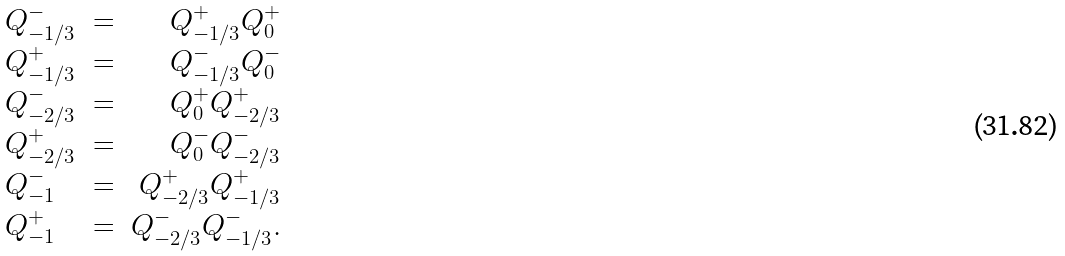<formula> <loc_0><loc_0><loc_500><loc_500>\begin{array} { l c r } Q _ { - 1 / 3 } ^ { - } & = & Q _ { - 1 / 3 } ^ { + } Q _ { 0 } ^ { + } \\ Q _ { - 1 / 3 } ^ { + } & = & Q _ { - 1 / 3 } ^ { - } Q _ { 0 } ^ { - } \\ Q _ { - 2 / 3 } ^ { - } & = & Q _ { 0 } ^ { + } Q _ { - 2 / 3 } ^ { + } \\ Q _ { - 2 / 3 } ^ { + } & = & Q _ { 0 } ^ { - } Q _ { - 2 / 3 } ^ { - } \\ Q _ { - 1 } ^ { - } & = & Q _ { - 2 / 3 } ^ { + } Q _ { - 1 / 3 } ^ { + } \\ Q _ { - 1 } ^ { + } & = & Q _ { - 2 / 3 } ^ { - } Q _ { - 1 / 3 } ^ { - } . \\ \end{array}</formula> 